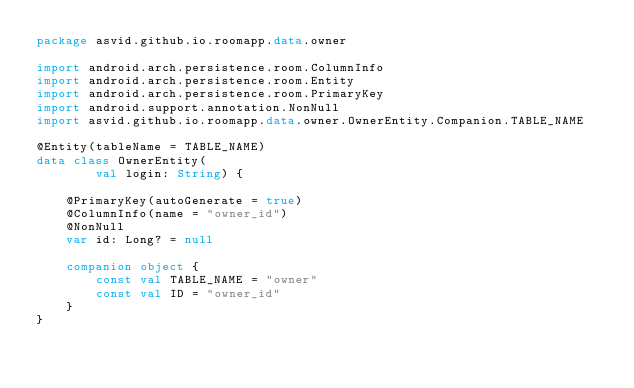Convert code to text. <code><loc_0><loc_0><loc_500><loc_500><_Kotlin_>package asvid.github.io.roomapp.data.owner

import android.arch.persistence.room.ColumnInfo
import android.arch.persistence.room.Entity
import android.arch.persistence.room.PrimaryKey
import android.support.annotation.NonNull
import asvid.github.io.roomapp.data.owner.OwnerEntity.Companion.TABLE_NAME

@Entity(tableName = TABLE_NAME)
data class OwnerEntity(
        val login: String) {

    @PrimaryKey(autoGenerate = true)
    @ColumnInfo(name = "owner_id")
    @NonNull
    var id: Long? = null

    companion object {
        const val TABLE_NAME = "owner"
        const val ID = "owner_id"
    }
}</code> 